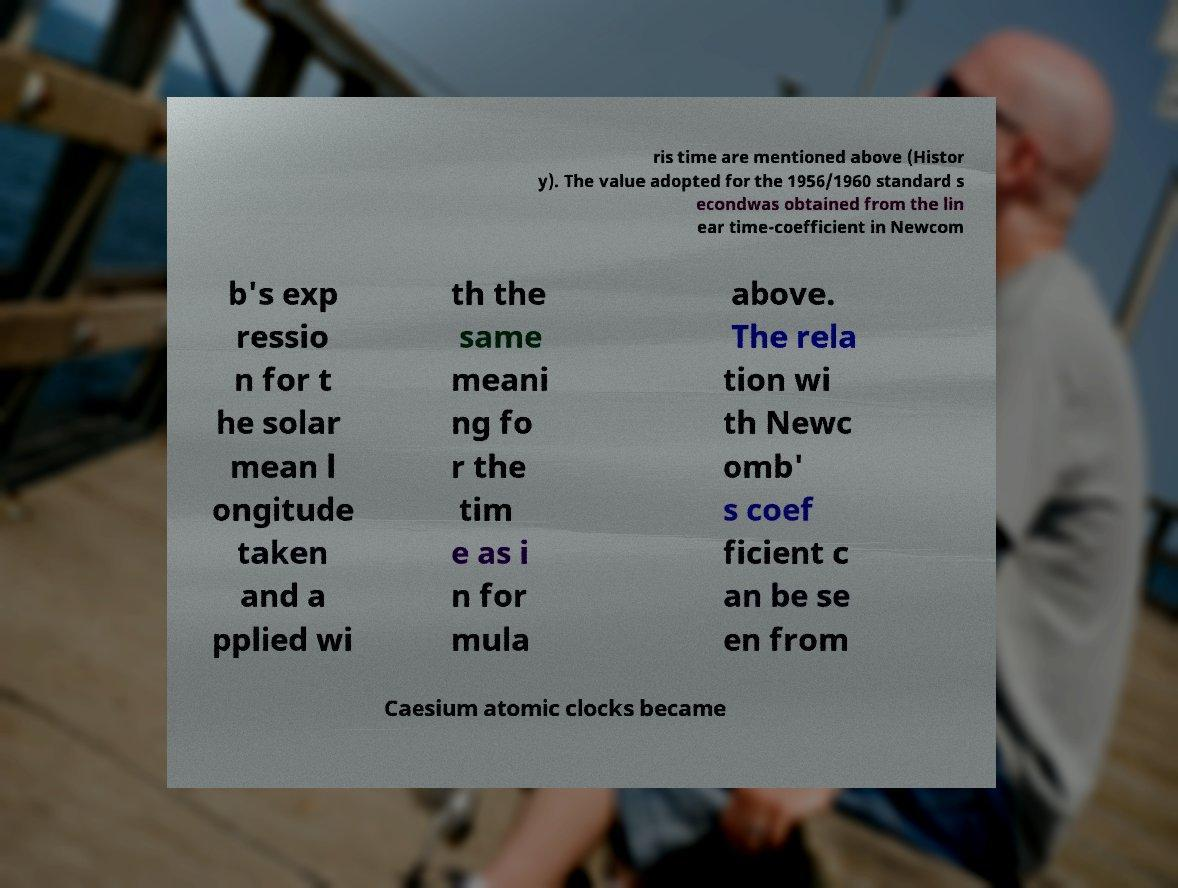Could you extract and type out the text from this image? ris time are mentioned above (Histor y). The value adopted for the 1956/1960 standard s econdwas obtained from the lin ear time-coefficient in Newcom b's exp ressio n for t he solar mean l ongitude taken and a pplied wi th the same meani ng fo r the tim e as i n for mula above. The rela tion wi th Newc omb' s coef ficient c an be se en from Caesium atomic clocks became 